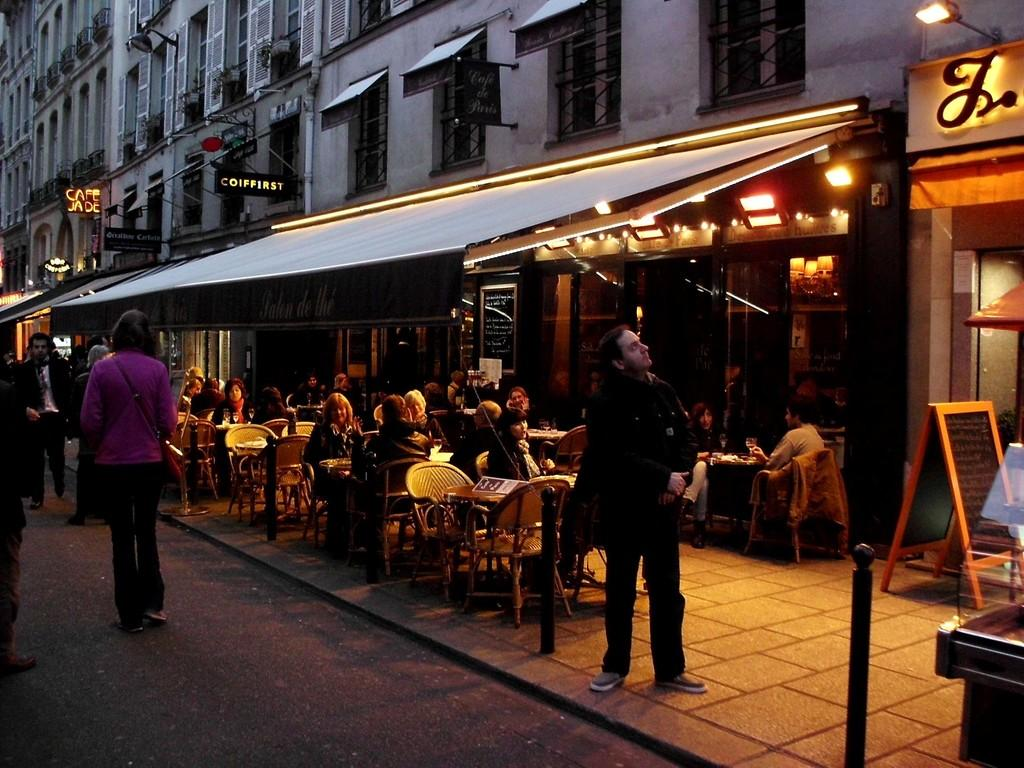What type of structure is visible in the image? There is a building in the image. Who is present in the image? There are men standing and seated on chairs in the image. Can you describe the positions of the men in the image? Some men are standing, while others are seated on chairs. What type of education is being offered to the beginner skiers on the slope in the image? There is no mention of skiing, beginners, or a slope in the image. The image features a building and men standing or seated on chairs. 